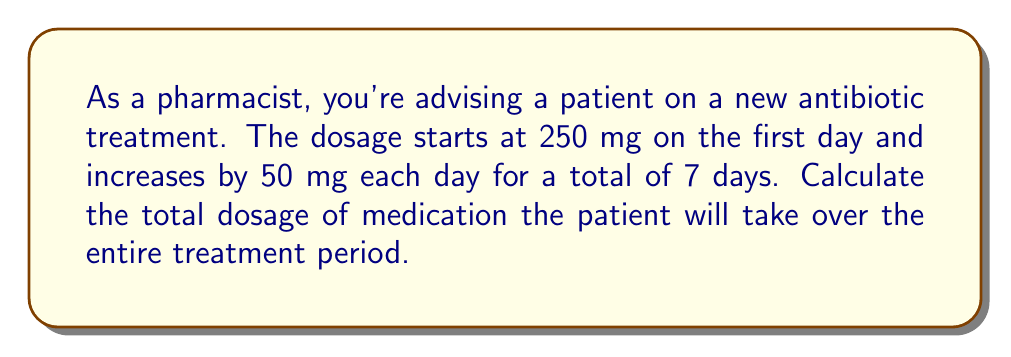Show me your answer to this math problem. Let's approach this step-by-step using an arithmetic series:

1) First, identify the components of the arithmetic sequence:
   - First term (a₁) = 250 mg
   - Common difference (d) = 50 mg
   - Number of terms (n) = 7 days

2) The sequence of daily doses will be:
   250, 300, 350, 400, 450, 500, 550

3) For an arithmetic sequence, we can use the formula for the sum of an arithmetic series:

   $$S_n = \frac{n}{2}(a_1 + a_n)$$

   Where:
   $S_n$ is the sum of the series
   $n$ is the number of terms
   $a_1$ is the first term
   $a_n$ is the last term

4) We know $a_1 = 250$ and $n = 7$, but we need to calculate $a_n$:
   
   $$a_n = a_1 + (n-1)d$$
   $$a_7 = 250 + (7-1)50 = 250 + 300 = 550$$

5) Now we can plug these values into our sum formula:

   $$S_7 = \frac{7}{2}(250 + 550)$$
   $$S_7 = \frac{7}{2}(800)$$
   $$S_7 = 7(400)$$
   $$S_7 = 2800$$

Therefore, the total dosage over the 7-day treatment period is 2800 mg.
Answer: 2800 mg 